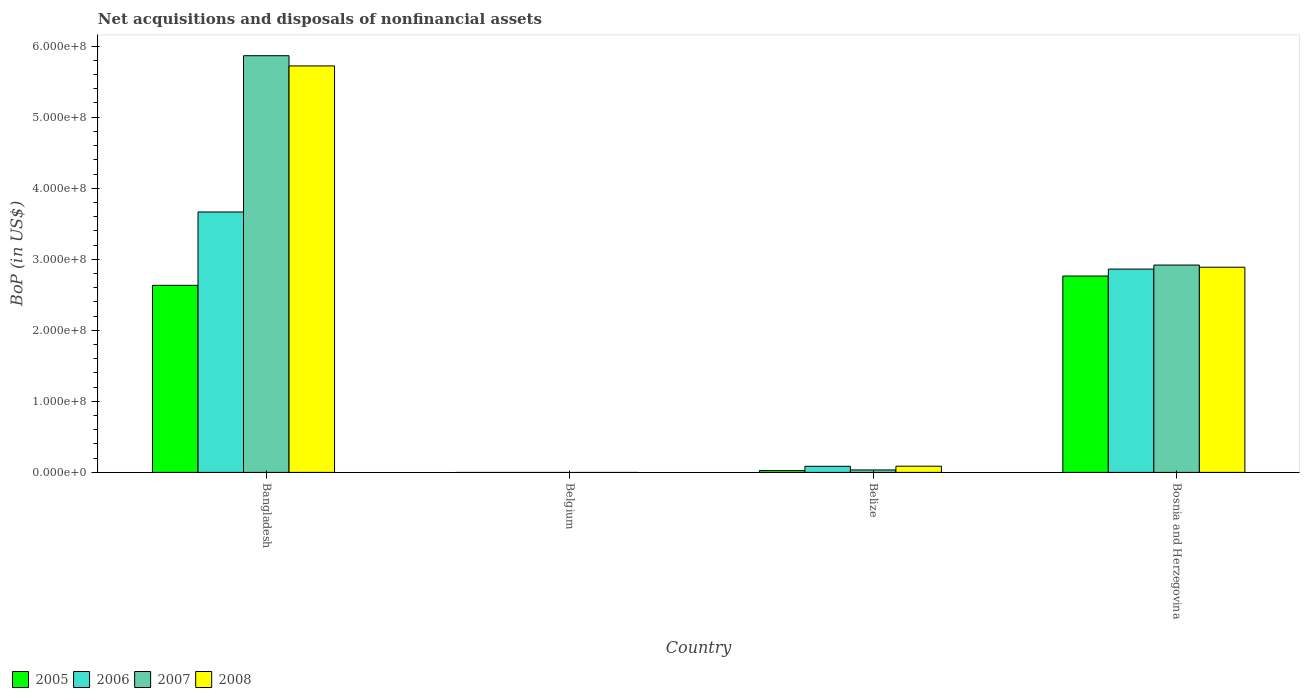How many different coloured bars are there?
Make the answer very short. 4. Are the number of bars per tick equal to the number of legend labels?
Your answer should be very brief. No. How many bars are there on the 2nd tick from the left?
Keep it short and to the point. 0. In how many cases, is the number of bars for a given country not equal to the number of legend labels?
Provide a succinct answer. 1. What is the Balance of Payments in 2007 in Belize?
Ensure brevity in your answer.  3.45e+06. Across all countries, what is the maximum Balance of Payments in 2005?
Provide a succinct answer. 2.76e+08. Across all countries, what is the minimum Balance of Payments in 2007?
Your response must be concise. 0. In which country was the Balance of Payments in 2005 maximum?
Offer a terse response. Bosnia and Herzegovina. What is the total Balance of Payments in 2008 in the graph?
Ensure brevity in your answer.  8.70e+08. What is the difference between the Balance of Payments in 2008 in Belize and that in Bosnia and Herzegovina?
Offer a very short reply. -2.80e+08. What is the difference between the Balance of Payments in 2007 in Bangladesh and the Balance of Payments in 2008 in Bosnia and Herzegovina?
Provide a short and direct response. 2.98e+08. What is the average Balance of Payments in 2005 per country?
Offer a very short reply. 1.36e+08. What is the difference between the Balance of Payments of/in 2008 and Balance of Payments of/in 2005 in Bangladesh?
Give a very brief answer. 3.09e+08. In how many countries, is the Balance of Payments in 2008 greater than 180000000 US$?
Your response must be concise. 2. What is the ratio of the Balance of Payments in 2008 in Bangladesh to that in Belize?
Keep it short and to the point. 65.57. What is the difference between the highest and the second highest Balance of Payments in 2007?
Your answer should be compact. -2.95e+08. What is the difference between the highest and the lowest Balance of Payments in 2007?
Your response must be concise. 5.87e+08. In how many countries, is the Balance of Payments in 2005 greater than the average Balance of Payments in 2005 taken over all countries?
Your answer should be compact. 2. Is the sum of the Balance of Payments in 2006 in Belize and Bosnia and Herzegovina greater than the maximum Balance of Payments in 2007 across all countries?
Your response must be concise. No. What is the difference between two consecutive major ticks on the Y-axis?
Make the answer very short. 1.00e+08. How many legend labels are there?
Make the answer very short. 4. What is the title of the graph?
Your answer should be very brief. Net acquisitions and disposals of nonfinancial assets. What is the label or title of the Y-axis?
Provide a succinct answer. BoP (in US$). What is the BoP (in US$) of 2005 in Bangladesh?
Provide a short and direct response. 2.63e+08. What is the BoP (in US$) in 2006 in Bangladesh?
Your response must be concise. 3.67e+08. What is the BoP (in US$) of 2007 in Bangladesh?
Provide a short and direct response. 5.87e+08. What is the BoP (in US$) of 2008 in Bangladesh?
Provide a succinct answer. 5.72e+08. What is the BoP (in US$) in 2006 in Belgium?
Your response must be concise. 0. What is the BoP (in US$) in 2005 in Belize?
Provide a short and direct response. 2.59e+06. What is the BoP (in US$) of 2006 in Belize?
Give a very brief answer. 8.57e+06. What is the BoP (in US$) in 2007 in Belize?
Keep it short and to the point. 3.45e+06. What is the BoP (in US$) in 2008 in Belize?
Offer a very short reply. 8.73e+06. What is the BoP (in US$) of 2005 in Bosnia and Herzegovina?
Provide a short and direct response. 2.76e+08. What is the BoP (in US$) in 2006 in Bosnia and Herzegovina?
Offer a very short reply. 2.86e+08. What is the BoP (in US$) in 2007 in Bosnia and Herzegovina?
Your answer should be compact. 2.92e+08. What is the BoP (in US$) in 2008 in Bosnia and Herzegovina?
Offer a terse response. 2.89e+08. Across all countries, what is the maximum BoP (in US$) in 2005?
Your answer should be compact. 2.76e+08. Across all countries, what is the maximum BoP (in US$) in 2006?
Keep it short and to the point. 3.67e+08. Across all countries, what is the maximum BoP (in US$) in 2007?
Ensure brevity in your answer.  5.87e+08. Across all countries, what is the maximum BoP (in US$) of 2008?
Give a very brief answer. 5.72e+08. Across all countries, what is the minimum BoP (in US$) in 2005?
Your response must be concise. 0. Across all countries, what is the minimum BoP (in US$) of 2007?
Give a very brief answer. 0. Across all countries, what is the minimum BoP (in US$) of 2008?
Offer a very short reply. 0. What is the total BoP (in US$) in 2005 in the graph?
Give a very brief answer. 5.42e+08. What is the total BoP (in US$) in 2006 in the graph?
Provide a short and direct response. 6.61e+08. What is the total BoP (in US$) of 2007 in the graph?
Offer a very short reply. 8.82e+08. What is the total BoP (in US$) of 2008 in the graph?
Your answer should be very brief. 8.70e+08. What is the difference between the BoP (in US$) in 2005 in Bangladesh and that in Belize?
Your response must be concise. 2.61e+08. What is the difference between the BoP (in US$) of 2006 in Bangladesh and that in Belize?
Ensure brevity in your answer.  3.58e+08. What is the difference between the BoP (in US$) in 2007 in Bangladesh and that in Belize?
Ensure brevity in your answer.  5.83e+08. What is the difference between the BoP (in US$) in 2008 in Bangladesh and that in Belize?
Offer a very short reply. 5.63e+08. What is the difference between the BoP (in US$) in 2005 in Bangladesh and that in Bosnia and Herzegovina?
Make the answer very short. -1.31e+07. What is the difference between the BoP (in US$) of 2006 in Bangladesh and that in Bosnia and Herzegovina?
Your answer should be very brief. 8.04e+07. What is the difference between the BoP (in US$) in 2007 in Bangladesh and that in Bosnia and Herzegovina?
Keep it short and to the point. 2.95e+08. What is the difference between the BoP (in US$) of 2008 in Bangladesh and that in Bosnia and Herzegovina?
Your answer should be compact. 2.83e+08. What is the difference between the BoP (in US$) of 2005 in Belize and that in Bosnia and Herzegovina?
Ensure brevity in your answer.  -2.74e+08. What is the difference between the BoP (in US$) in 2006 in Belize and that in Bosnia and Herzegovina?
Your answer should be compact. -2.78e+08. What is the difference between the BoP (in US$) of 2007 in Belize and that in Bosnia and Herzegovina?
Your answer should be compact. -2.88e+08. What is the difference between the BoP (in US$) of 2008 in Belize and that in Bosnia and Herzegovina?
Make the answer very short. -2.80e+08. What is the difference between the BoP (in US$) of 2005 in Bangladesh and the BoP (in US$) of 2006 in Belize?
Provide a short and direct response. 2.55e+08. What is the difference between the BoP (in US$) of 2005 in Bangladesh and the BoP (in US$) of 2007 in Belize?
Your answer should be compact. 2.60e+08. What is the difference between the BoP (in US$) in 2005 in Bangladesh and the BoP (in US$) in 2008 in Belize?
Give a very brief answer. 2.55e+08. What is the difference between the BoP (in US$) of 2006 in Bangladesh and the BoP (in US$) of 2007 in Belize?
Ensure brevity in your answer.  3.63e+08. What is the difference between the BoP (in US$) in 2006 in Bangladesh and the BoP (in US$) in 2008 in Belize?
Offer a very short reply. 3.58e+08. What is the difference between the BoP (in US$) in 2007 in Bangladesh and the BoP (in US$) in 2008 in Belize?
Your answer should be very brief. 5.78e+08. What is the difference between the BoP (in US$) in 2005 in Bangladesh and the BoP (in US$) in 2006 in Bosnia and Herzegovina?
Your answer should be very brief. -2.29e+07. What is the difference between the BoP (in US$) of 2005 in Bangladesh and the BoP (in US$) of 2007 in Bosnia and Herzegovina?
Provide a short and direct response. -2.85e+07. What is the difference between the BoP (in US$) in 2005 in Bangladesh and the BoP (in US$) in 2008 in Bosnia and Herzegovina?
Your answer should be compact. -2.55e+07. What is the difference between the BoP (in US$) in 2006 in Bangladesh and the BoP (in US$) in 2007 in Bosnia and Herzegovina?
Provide a succinct answer. 7.47e+07. What is the difference between the BoP (in US$) of 2006 in Bangladesh and the BoP (in US$) of 2008 in Bosnia and Herzegovina?
Your answer should be compact. 7.78e+07. What is the difference between the BoP (in US$) in 2007 in Bangladesh and the BoP (in US$) in 2008 in Bosnia and Herzegovina?
Provide a short and direct response. 2.98e+08. What is the difference between the BoP (in US$) of 2005 in Belize and the BoP (in US$) of 2006 in Bosnia and Herzegovina?
Provide a succinct answer. -2.84e+08. What is the difference between the BoP (in US$) in 2005 in Belize and the BoP (in US$) in 2007 in Bosnia and Herzegovina?
Make the answer very short. -2.89e+08. What is the difference between the BoP (in US$) in 2005 in Belize and the BoP (in US$) in 2008 in Bosnia and Herzegovina?
Give a very brief answer. -2.86e+08. What is the difference between the BoP (in US$) in 2006 in Belize and the BoP (in US$) in 2007 in Bosnia and Herzegovina?
Keep it short and to the point. -2.83e+08. What is the difference between the BoP (in US$) in 2006 in Belize and the BoP (in US$) in 2008 in Bosnia and Herzegovina?
Provide a short and direct response. -2.80e+08. What is the difference between the BoP (in US$) of 2007 in Belize and the BoP (in US$) of 2008 in Bosnia and Herzegovina?
Provide a succinct answer. -2.85e+08. What is the average BoP (in US$) of 2005 per country?
Give a very brief answer. 1.36e+08. What is the average BoP (in US$) of 2006 per country?
Make the answer very short. 1.65e+08. What is the average BoP (in US$) of 2007 per country?
Keep it short and to the point. 2.20e+08. What is the average BoP (in US$) of 2008 per country?
Your response must be concise. 2.17e+08. What is the difference between the BoP (in US$) in 2005 and BoP (in US$) in 2006 in Bangladesh?
Keep it short and to the point. -1.03e+08. What is the difference between the BoP (in US$) in 2005 and BoP (in US$) in 2007 in Bangladesh?
Provide a succinct answer. -3.23e+08. What is the difference between the BoP (in US$) of 2005 and BoP (in US$) of 2008 in Bangladesh?
Keep it short and to the point. -3.09e+08. What is the difference between the BoP (in US$) in 2006 and BoP (in US$) in 2007 in Bangladesh?
Your answer should be very brief. -2.20e+08. What is the difference between the BoP (in US$) in 2006 and BoP (in US$) in 2008 in Bangladesh?
Give a very brief answer. -2.06e+08. What is the difference between the BoP (in US$) of 2007 and BoP (in US$) of 2008 in Bangladesh?
Your answer should be compact. 1.44e+07. What is the difference between the BoP (in US$) of 2005 and BoP (in US$) of 2006 in Belize?
Offer a terse response. -5.98e+06. What is the difference between the BoP (in US$) of 2005 and BoP (in US$) of 2007 in Belize?
Provide a succinct answer. -8.56e+05. What is the difference between the BoP (in US$) in 2005 and BoP (in US$) in 2008 in Belize?
Offer a terse response. -6.14e+06. What is the difference between the BoP (in US$) of 2006 and BoP (in US$) of 2007 in Belize?
Provide a succinct answer. 5.12e+06. What is the difference between the BoP (in US$) of 2006 and BoP (in US$) of 2008 in Belize?
Provide a succinct answer. -1.61e+05. What is the difference between the BoP (in US$) in 2007 and BoP (in US$) in 2008 in Belize?
Provide a short and direct response. -5.28e+06. What is the difference between the BoP (in US$) of 2005 and BoP (in US$) of 2006 in Bosnia and Herzegovina?
Your answer should be compact. -9.77e+06. What is the difference between the BoP (in US$) of 2005 and BoP (in US$) of 2007 in Bosnia and Herzegovina?
Your answer should be compact. -1.54e+07. What is the difference between the BoP (in US$) of 2005 and BoP (in US$) of 2008 in Bosnia and Herzegovina?
Ensure brevity in your answer.  -1.24e+07. What is the difference between the BoP (in US$) of 2006 and BoP (in US$) of 2007 in Bosnia and Herzegovina?
Your response must be concise. -5.67e+06. What is the difference between the BoP (in US$) of 2006 and BoP (in US$) of 2008 in Bosnia and Herzegovina?
Offer a very short reply. -2.60e+06. What is the difference between the BoP (in US$) of 2007 and BoP (in US$) of 2008 in Bosnia and Herzegovina?
Offer a very short reply. 3.07e+06. What is the ratio of the BoP (in US$) of 2005 in Bangladesh to that in Belize?
Your answer should be compact. 101.69. What is the ratio of the BoP (in US$) in 2006 in Bangladesh to that in Belize?
Provide a short and direct response. 42.8. What is the ratio of the BoP (in US$) in 2007 in Bangladesh to that in Belize?
Your response must be concise. 170.21. What is the ratio of the BoP (in US$) in 2008 in Bangladesh to that in Belize?
Offer a very short reply. 65.57. What is the ratio of the BoP (in US$) of 2005 in Bangladesh to that in Bosnia and Herzegovina?
Your answer should be compact. 0.95. What is the ratio of the BoP (in US$) of 2006 in Bangladesh to that in Bosnia and Herzegovina?
Offer a very short reply. 1.28. What is the ratio of the BoP (in US$) in 2007 in Bangladesh to that in Bosnia and Herzegovina?
Give a very brief answer. 2.01. What is the ratio of the BoP (in US$) in 2008 in Bangladesh to that in Bosnia and Herzegovina?
Your answer should be very brief. 1.98. What is the ratio of the BoP (in US$) in 2005 in Belize to that in Bosnia and Herzegovina?
Provide a short and direct response. 0.01. What is the ratio of the BoP (in US$) in 2006 in Belize to that in Bosnia and Herzegovina?
Offer a very short reply. 0.03. What is the ratio of the BoP (in US$) in 2007 in Belize to that in Bosnia and Herzegovina?
Provide a succinct answer. 0.01. What is the ratio of the BoP (in US$) of 2008 in Belize to that in Bosnia and Herzegovina?
Provide a succinct answer. 0.03. What is the difference between the highest and the second highest BoP (in US$) of 2005?
Your answer should be very brief. 1.31e+07. What is the difference between the highest and the second highest BoP (in US$) of 2006?
Your answer should be compact. 8.04e+07. What is the difference between the highest and the second highest BoP (in US$) of 2007?
Provide a short and direct response. 2.95e+08. What is the difference between the highest and the second highest BoP (in US$) of 2008?
Provide a succinct answer. 2.83e+08. What is the difference between the highest and the lowest BoP (in US$) of 2005?
Ensure brevity in your answer.  2.76e+08. What is the difference between the highest and the lowest BoP (in US$) in 2006?
Give a very brief answer. 3.67e+08. What is the difference between the highest and the lowest BoP (in US$) in 2007?
Ensure brevity in your answer.  5.87e+08. What is the difference between the highest and the lowest BoP (in US$) of 2008?
Provide a succinct answer. 5.72e+08. 